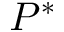Convert formula to latex. <formula><loc_0><loc_0><loc_500><loc_500>P ^ { * }</formula> 